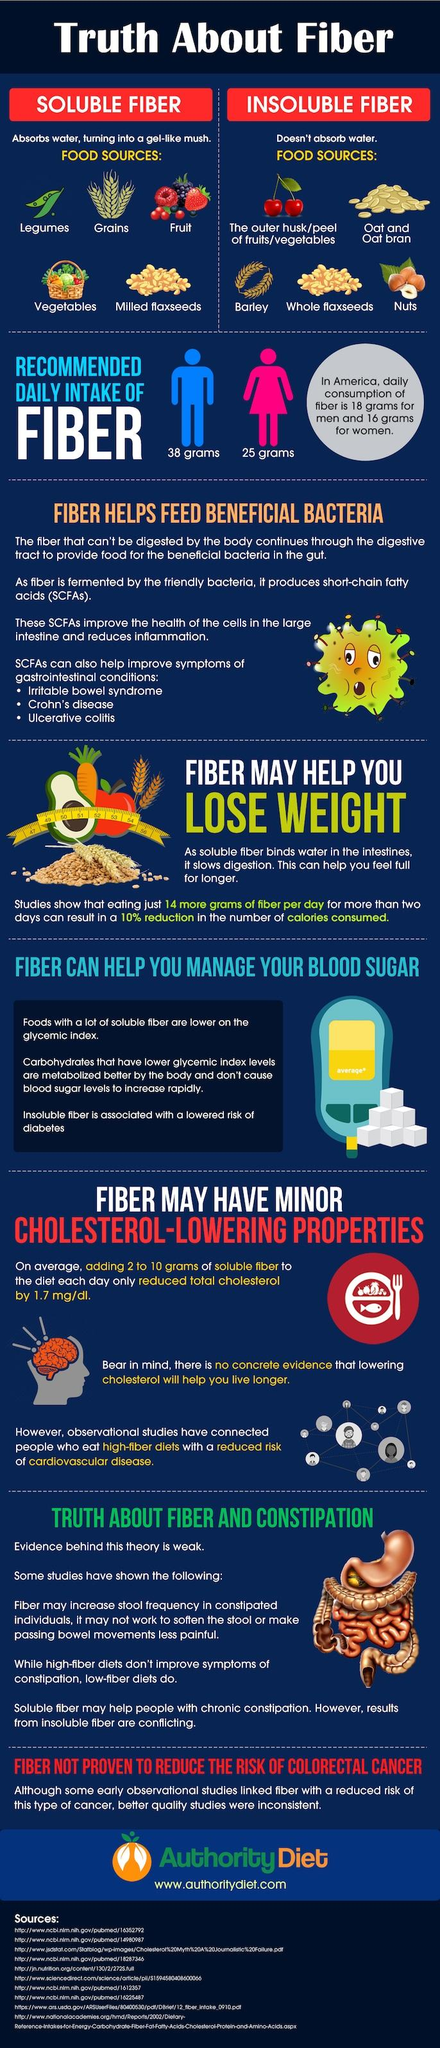Give some essential details in this illustration. Men have a higher recommended daily intake of fiber than women, according to the . The number of sources listed at the bottom is 10. The daily intake and recommended intake of fibers for women in America are 9 grams, respectively. 